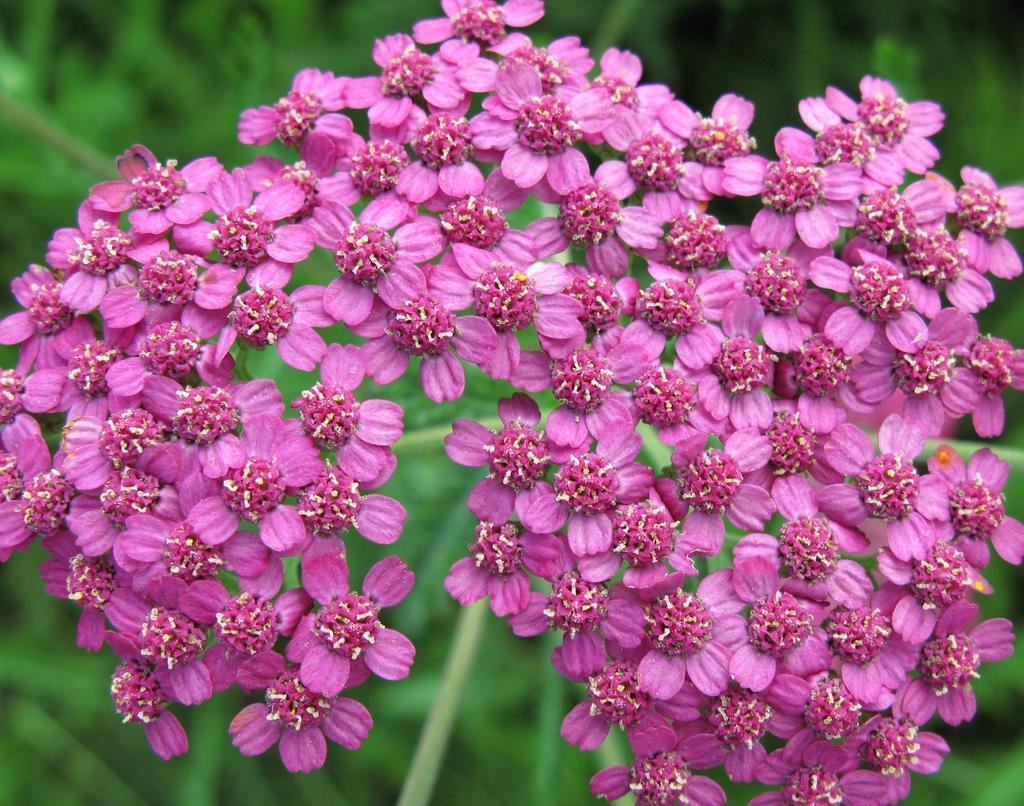What type of flowers can be seen in the image? There are pink flowers in the image. Can you describe the background of the image? The background of the image is blurred. Where is the sink located in the image? There is no sink present in the image. What type of glue is being used to hold the flowers together in the image? There is no glue or indication of the flowers being held together in the image. 